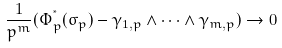<formula> <loc_0><loc_0><loc_500><loc_500>\frac { 1 } { p ^ { m } } ( \Phi _ { p } ^ { ^ { * } } ( \sigma _ { p } ) - \gamma _ { 1 , p } \wedge \dots \wedge \gamma _ { m , p } ) \rightarrow 0</formula> 